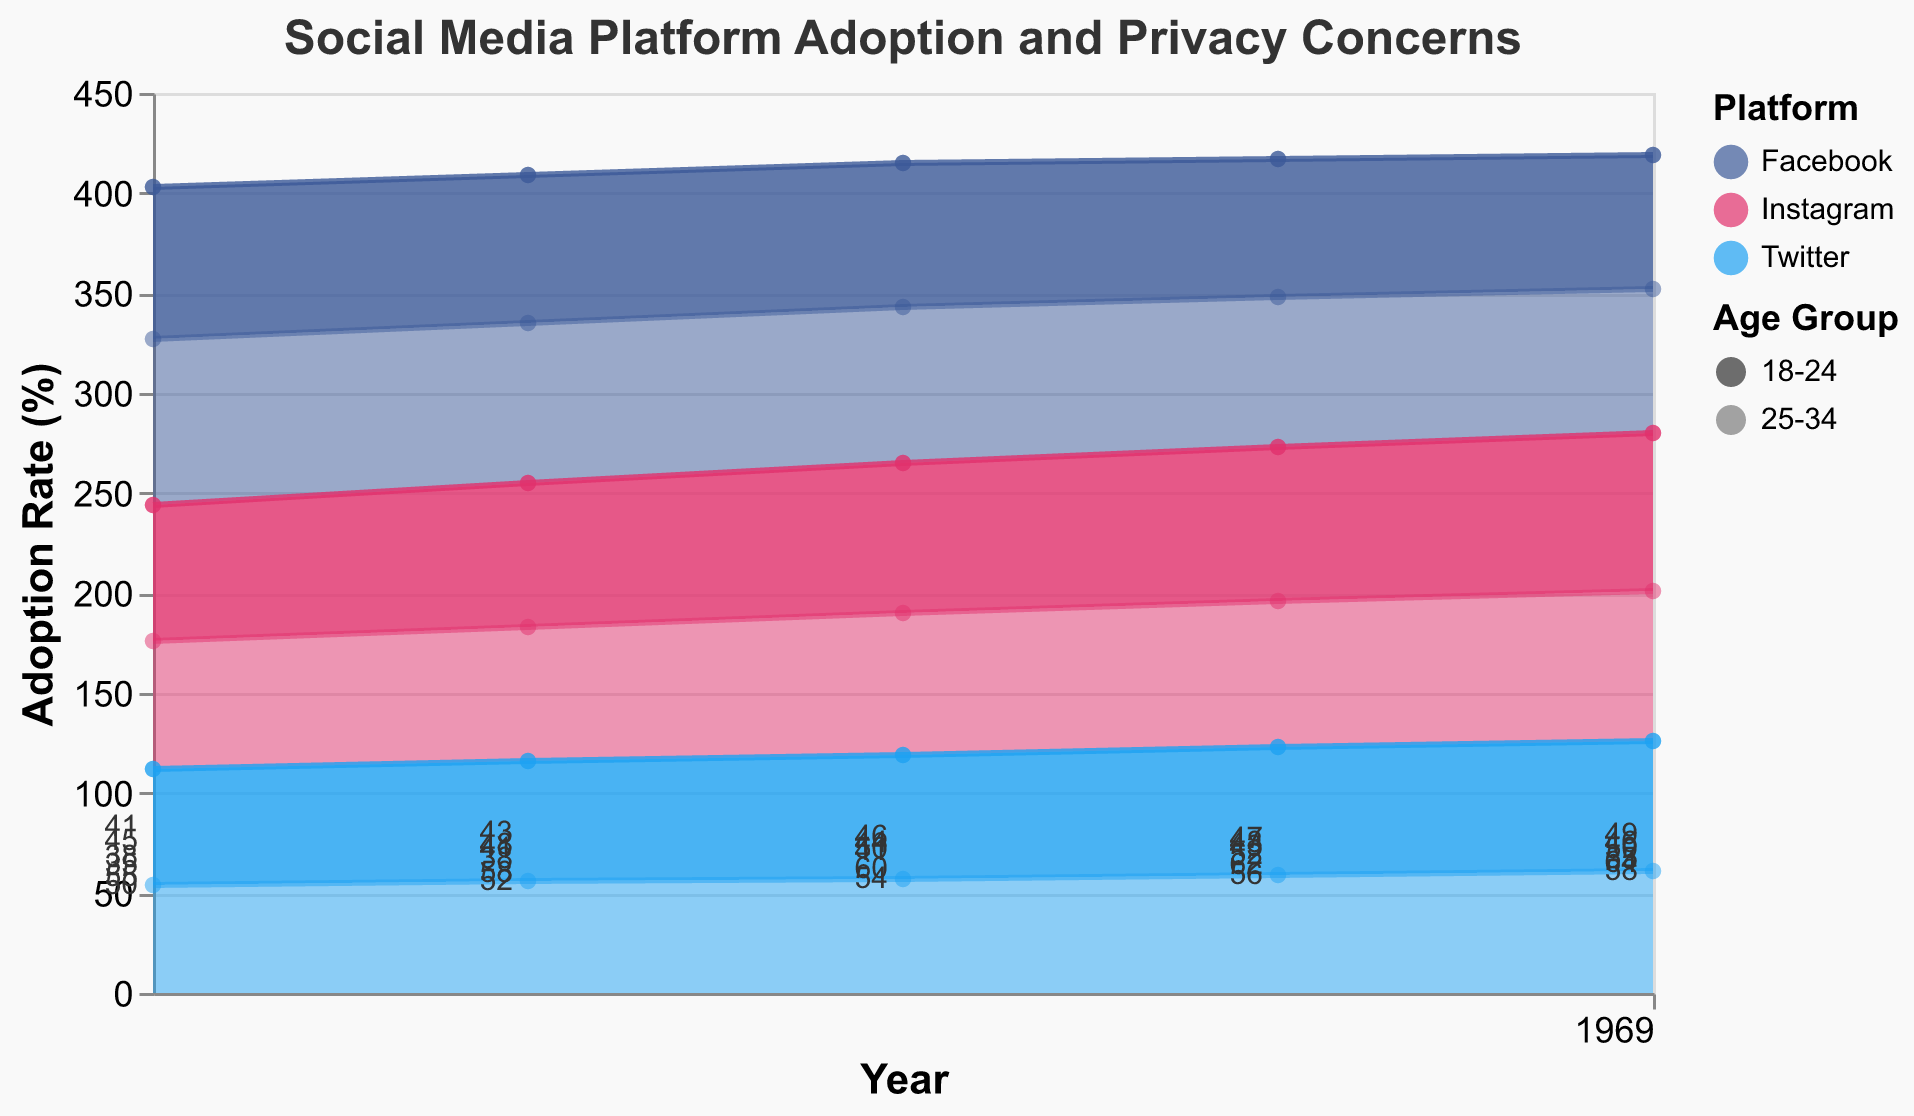What is the title of the area chart? The title is displayed at the top of the chart. It is labeled as "Social Media Platform Adoption and Privacy Concerns."
Answer: Social Media Platform Adoption and Privacy Concerns Which platform among the 18-24 age group in 2021 has the highest adoption rate? To find the answer, look at the adoption rates in 2021 for different platforms within the 18-24 age group. Instagram has the highest adoption rate of 79%.
Answer: Instagram How does the adoption rate of Facebook change for the 25-34 age group from 2017 to 2021? Look at the adoption rate of Facebook in the 25-34 age group from 2017 to 2021. It decreases from 83% in 2017 to 72% in 2021.
Answer: It decreases Between Instagram and Twitter, which platform showed a higher increase in adoption rate among the 18-24 age group from 2017 to 2021? Calculate the increase for both platforms. For Instagram, it's 79% - 68% = 11%. For Twitter, it's 65% - 58% = 7%. Instagram showed a higher increase.
Answer: Instagram What is the average adoption rate of Twitter for the 25-34 age group over the years 2017 to 2021? Add the adoption rates for each year and divide by the number of years. (54 + 56 + 57 + 59 + 61) / 5 = 57.4%.
Answer: 57.4% Compare the privacy concerns cited for Facebook and Instagram in 2019 for the 18-24 age group. Which platform has higher privacy concerns cited? Look at the privacy concerns cited in 2019 for Facebook (50) and Instagram (44) among the 18-24 age group. Facebook has higher privacy concerns cited.
Answer: Facebook Which age group cites more privacy concerns for Twitter in 2021: 18-24 or 25-34? Compare the privacy concerns cited for Twitter in 2021 between the 18-24 age group (64) and the 25-34 age group (58). The 18-24 age group cites more privacy concerns.
Answer: 18-24 What trend is evident in the adoption rates of Facebook for the 18-24 age group from 2017 to 2021? Observe the trend over the years for the 18-24 age group. The adoption rate for Facebook consistently decreases each year from 76% in 2017 to 67% in 2021.
Answer: Decreasing trend Which three platforms are compared in this area chart? The legend and the color coding of the chart show that Facebook, Instagram, and Twitter are the three platforms compared.
Answer: Facebook, Instagram, and Twitter Summing up the adoption rates of Instagram for the 25-34 age group from 2017 to 2021 gives what total? Add the adoption rates from 2017 to 2021 for Instagram in the 25-34 age group: 64 + 67 + 71 + 73 + 75 = 350.
Answer: 350 